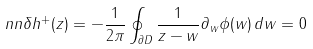Convert formula to latex. <formula><loc_0><loc_0><loc_500><loc_500>\ n n \delta h ^ { + } ( z ) = - \frac { 1 } { 2 \pi } \oint _ { \partial D } \frac { 1 } { z - w } \partial _ { w } \phi ( w ) \, d w = 0</formula> 